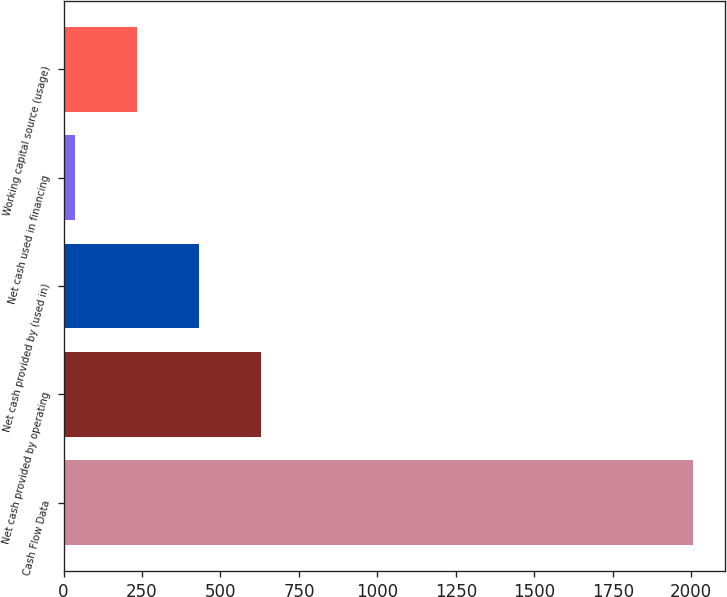<chart> <loc_0><loc_0><loc_500><loc_500><bar_chart><fcel>Cash Flow Data<fcel>Net cash provided by operating<fcel>Net cash provided by (used in)<fcel>Net cash used in financing<fcel>Working capital source (usage)<nl><fcel>2007<fcel>628.21<fcel>431.24<fcel>37.3<fcel>234.27<nl></chart> 